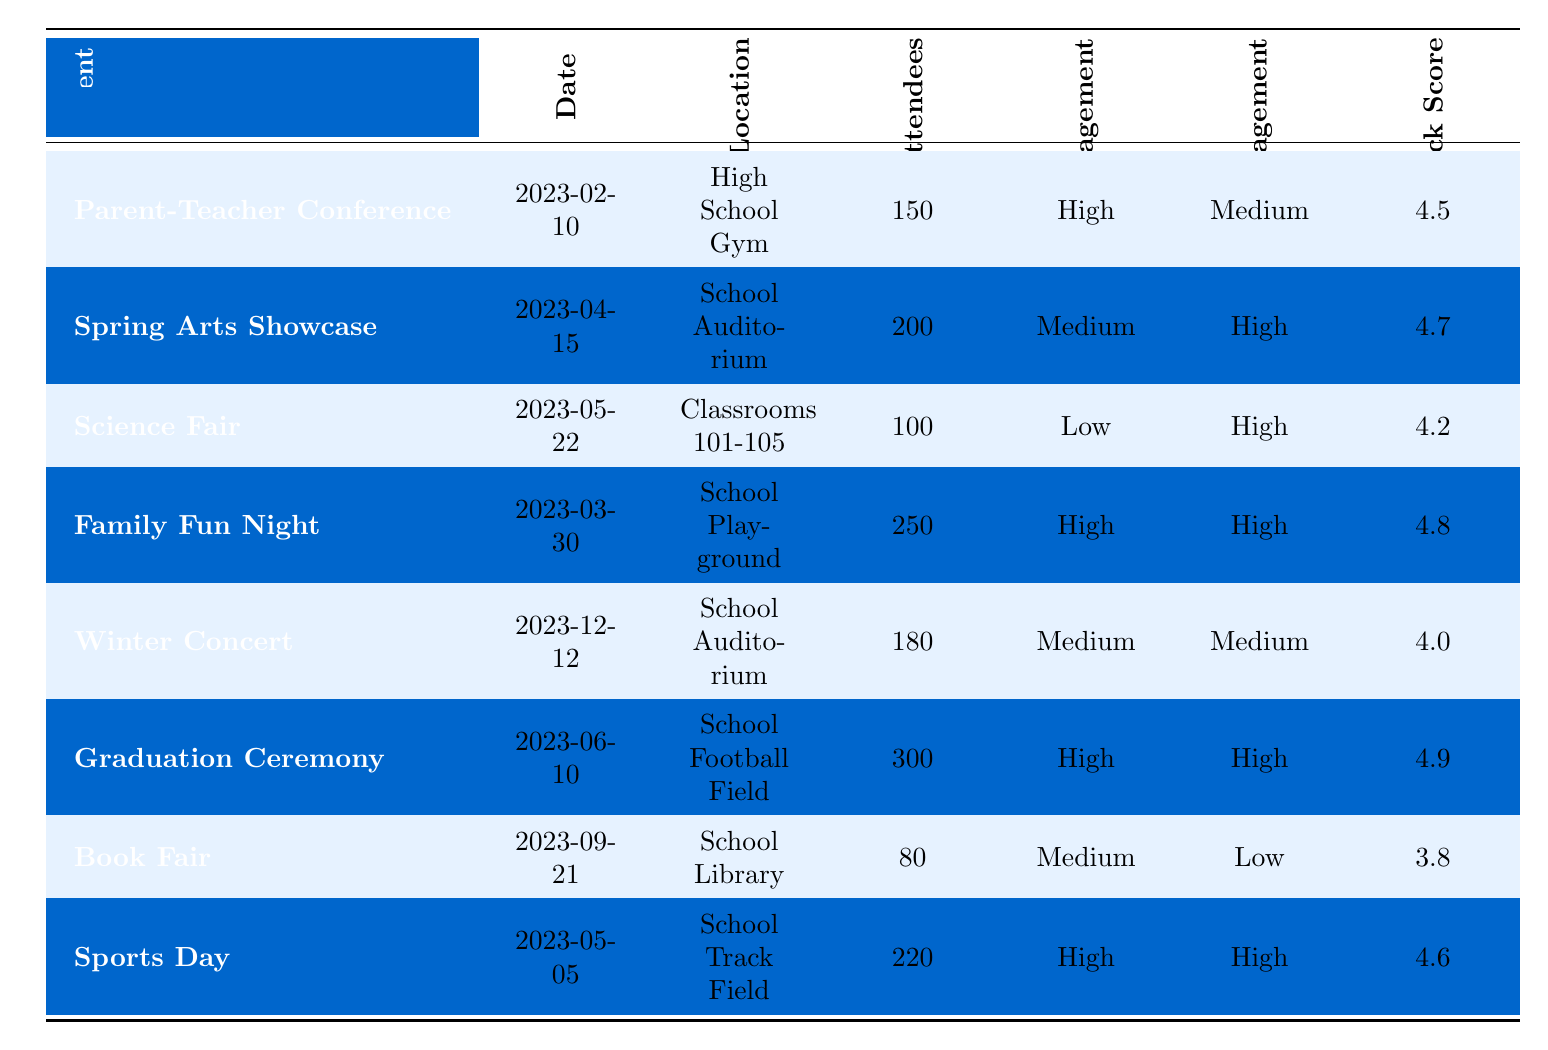What is the total number of attendees for the Family Fun Night? The table shows that the total number of attendees for the Family Fun Night is listed under the "Total Attendees" column, which is 250.
Answer: 250 Which event received the highest feedback score? By comparing the "Feedback Score" column, the Graduation Ceremony has the highest score of 4.9.
Answer: Graduation Ceremony How many events had high parent engagement? The events with high parent engagement are the Parent-Teacher Conference, Family Fun Night, Graduation Ceremony, and Sports Day. This totals to 4 events.
Answer: 4 What was the average feedback score for all events? The feedback scores are 4.5, 4.7, 4.2, 4.8, 4.0, 4.9, 3.8, and 4.6. Summing these up gives 4.5 + 4.7 + 4.2 + 4.8 + 4.0 + 4.9 + 3.8 + 4.6 = 30.5. Dividing by 8 (the number of events) results in 30.5 / 8 = 3.8125, which rounds to 3.81.
Answer: 3.81 Did the Science Fair have a high student engagement level? The table indicates the student engagement level for the Science Fair is "High," so the answer is yes.
Answer: Yes Which event had the lowest total attendance? The Book Fair has the lowest total attendance, with 80 attendees listed in the "Total Attendees" column.
Answer: Book Fair How many events occurred in the School Auditorium? The events listed in the School Auditorium are the Spring Arts Showcase and Winter Concert, which adds up to 2 events.
Answer: 2 Is there an event with both high parent and student engagement? The events with both high parent and student engagement are Family Fun Night, Graduation Ceremony, and Sports Day, confirming that there are several such events.
Answer: Yes What is the difference between the total attendees of the Graduation Ceremony and the Book Fair? The total attendees for the Graduation Ceremony is 300, while for the Book Fair it is 80. The difference is calculated as 300 - 80 = 220.
Answer: 220 How many events had a median feedback score of 4.5 or higher? Sorting the feedback scores gives: 3.8, 4.0, 4.2, 4.5, 4.6, 4.7, 4.8, 4.9. The middle scores (4th and 5th) are 4.5 and 4.6. There are 5 scores (4.5 and above: 4.5, 4.6, 4.7, 4.8, and 4.9) hence 5 events meet this criterion.
Answer: 5 What is the total attendance across all events? Adding together the total attendance from each event: 150 + 200 + 100 + 250 + 180 + 300 + 80 + 220 = 1480.
Answer: 1480 